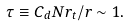<formula> <loc_0><loc_0><loc_500><loc_500>\tau \equiv C _ { d } N r _ { t } / r \sim 1 .</formula> 